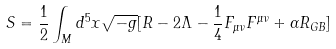Convert formula to latex. <formula><loc_0><loc_0><loc_500><loc_500>S = \frac { 1 } { 2 } \int _ { M } d ^ { 5 } x \sqrt { - g } [ R - 2 \Lambda - \frac { 1 } { 4 } F _ { \mu \nu } F ^ { \mu \nu } + \alpha R _ { G B } ]</formula> 